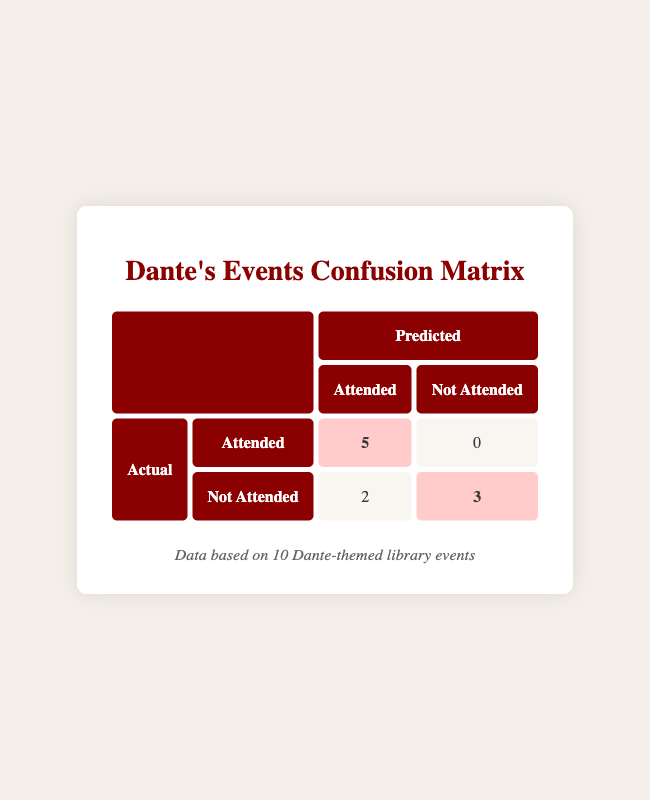What is the count of events where attendance was predicted to be "Yes" and it actually was? From the table, we see that the predicted "Yes" attended events have a count of 5 in the corresponding cell and reflect the actual attendance.
Answer: 5 How many events were predicted to have "Not Attended" but were actually attended? The table shows a count of 0 events in the cell where "Not Attended" is predicted and "Attended" is actual, indicating there were none.
Answer: 0 What is the total number of events listed in this confusion matrix? By counting all rows of events presented in the matrix, there are 10 total events, as shown in the footer of the table.
Answer: 10 How many events were planned with an attendance prediction of "Yes" but were not attended? The lower left cell of the matrix indicates there are 2 events that had an expected attendance of "Yes" but were not attended.
Answer: 2 What portion of the total events were attended according to the matrix? There were 5 attended events and 10 total events. Therefore, the portion is 5/10 = 0.5 or 50%.
Answer: 50% Were there any events that were both predicted and actual attendance "No"? Referring to the table, there are 3 events indicated in the cell where both predictions and actual attendance are "No."
Answer: Yes If we calculate the total events expected to be attended and the actual events attended, how many were "Not Attended"? Total expected attended is 7 (5+2) and actual attended is 5, so 7 - 5 = 2 events were expected to be attended but not.
Answer: 2 What percentage of events that were expected to have "Yes" attendance actually had "Yes"? There were 5 events that had "Yes" attendance predicted and it matches with attendance, so the percentage is (5/7)*100 = 71.43%.
Answer: 71.43% Which theme had a higher rate of actual attendance: those expected to be "Yes" or "No"? The events expected to be "Yes" had 5 attended out of 7, while those expected to be "No" had 3 attended out of 3. Therefore "Yes" has a higher rate.
Answer: Yes 